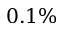Convert formula to latex. <formula><loc_0><loc_0><loc_500><loc_500>0 . 1 \%</formula> 